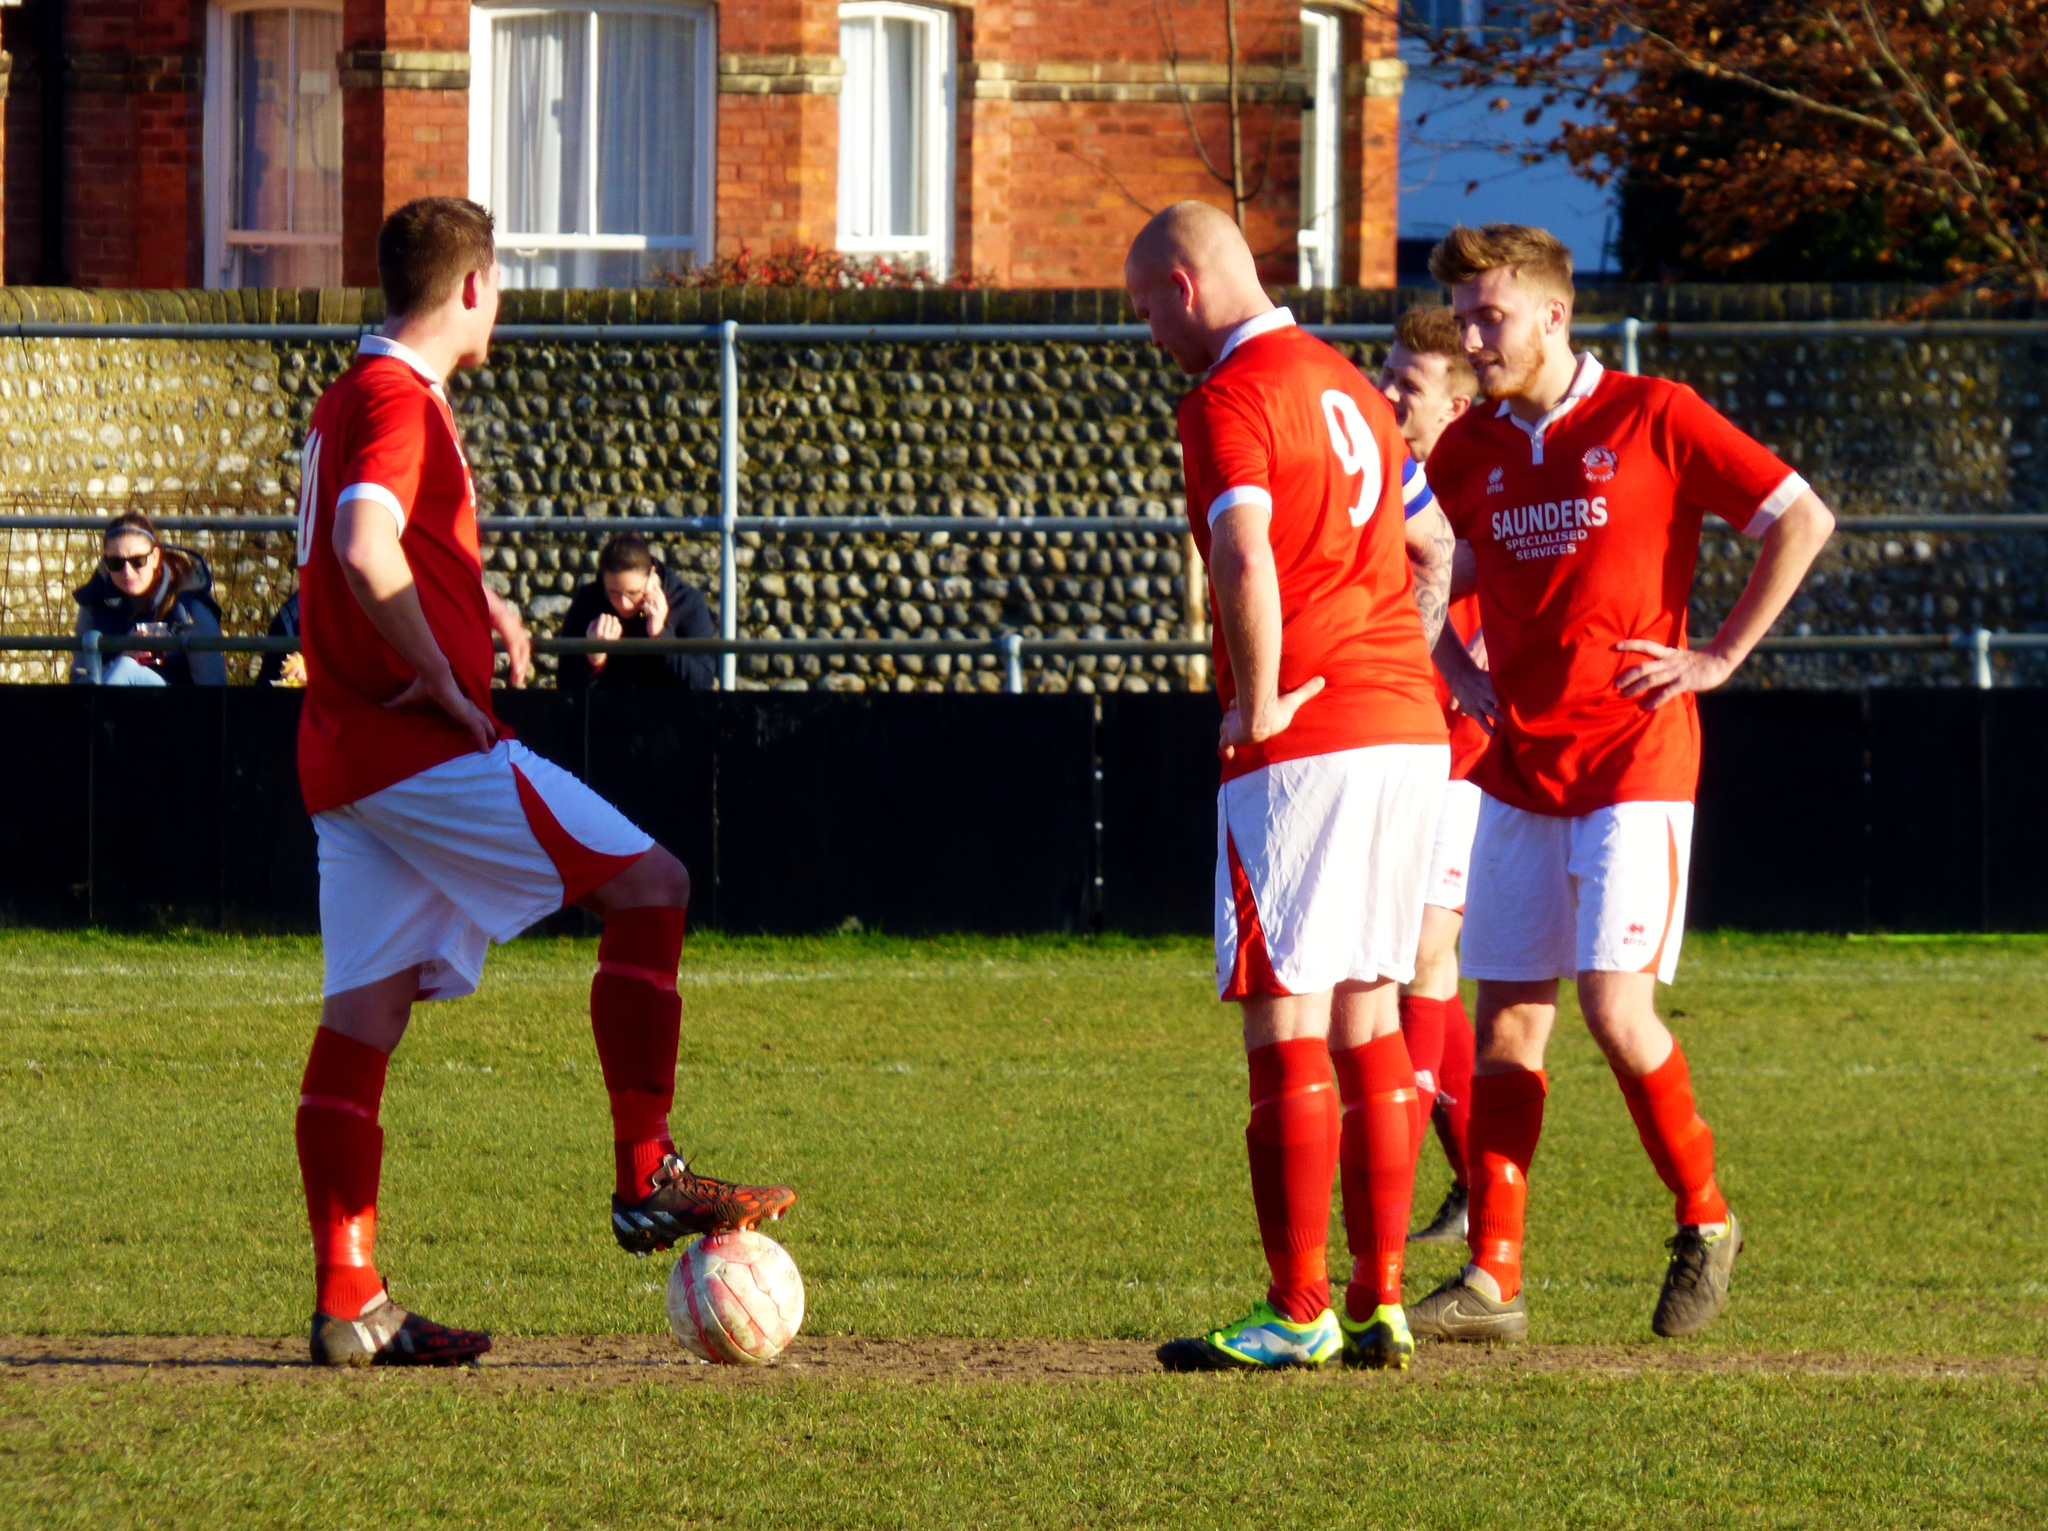What is the number of the player with his back turned?
Make the answer very short. 9. What is the sponsor name on the sports jersey?
Offer a very short reply. Saunders. 